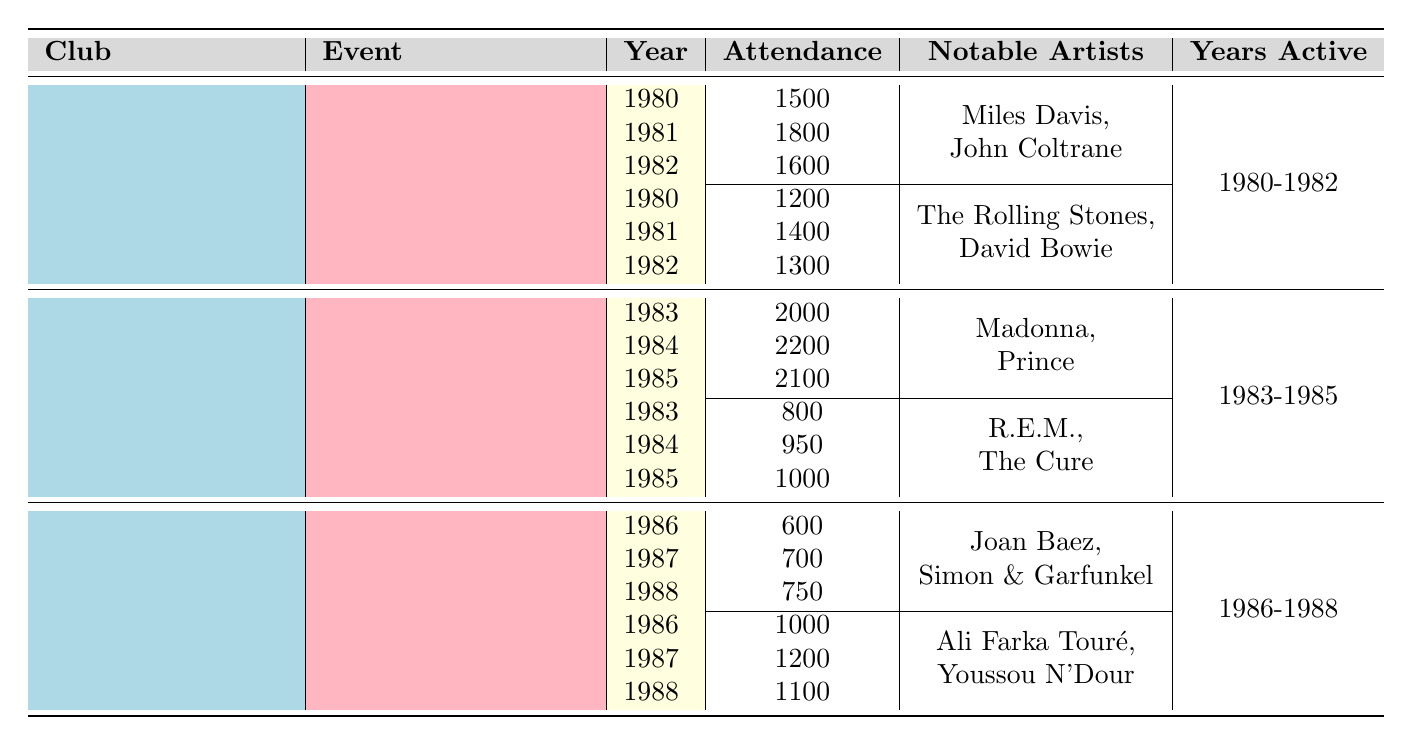What was the total attendance for Jazz Nights at Le Olympic in 1980? The attendance for Jazz Nights at Le Olympic in 1980 is listed as 1500.
Answer: 1500 Which club had the highest single event attendance in the data? Le Bataclan's Pop Music Nights in 1984 had the highest attendance of 2200.
Answer: Le Bataclan What was the average attendance for Folk Music Evenings across the three years at Le Café de la Danse? The attendances for Folk Music Evenings are 600, 700, and 750. Summing these gives 600 + 700 + 750 = 2050. Dividing by 3 gives an average of 2050/3 = 683.33, which rounds to 683.
Answer: 683 Did Le Olympic host any events featuring artists from the rock genre? Yes, Le Olympic hosted Rock Concerts featuring The Rolling Stones and David Bowie, which confirms the presence of rock genre artists.
Answer: Yes In which year did Le Bataclan host the lowest attendance for Indie Rock Shows? The attendance for Indie Rock Shows at Le Bataclan was 800 in 1983, which is lower than the subsequent years (950 in 1984 and 1000 in 1985).
Answer: 1983 What is the total attendance for all events at Le Café de la Danse in 1987? In 1987, the attendance for Folk Music Evenings was 700, and for World Music Festivals, it was 1200. Summing these gives 700 + 1200 = 1900.
Answer: 1900 How many years was Le Bataclan active for music events? Le Bataclan was active from 1983 to 1985, representing a total of three years of activity.
Answer: 3 Was the attendance for Pop Music Nights in 1983 higher than that for Jazz Nights in 1981? Yes, Pop Music Nights in 1983 had an attendance of 2000, while Jazz Nights in 1981 had 1800, making the Pop Music Nights higher.
Answer: Yes What was the overall trend in attendance for World Music Festivals at Le Café de la Danse from 1986 to 1988? The attendance for World Music Festivals was 1000 in 1986, increasing to 1200 in 1987, then decreasing to 1100 in 1988. This indicates a rise and then a drop, illustrating variability in attendance.
Answer: Rise then drop 